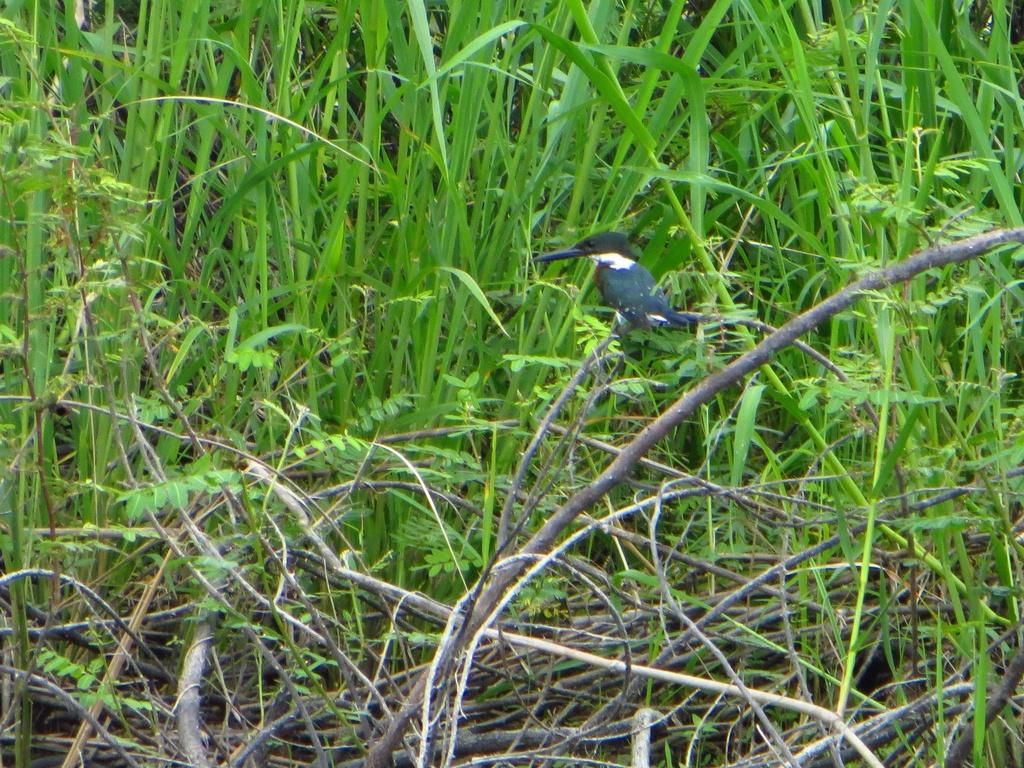What type of plant structures are present in the image? There are stems in the image. What type of vegetation is visible in the image? There is grass in the image. Can you describe the bird in the image? There is a bird on a stem in the image. What rhythm is the balloon following as it floats through the image? There is no balloon present in the image, so it cannot be following any rhythm. 